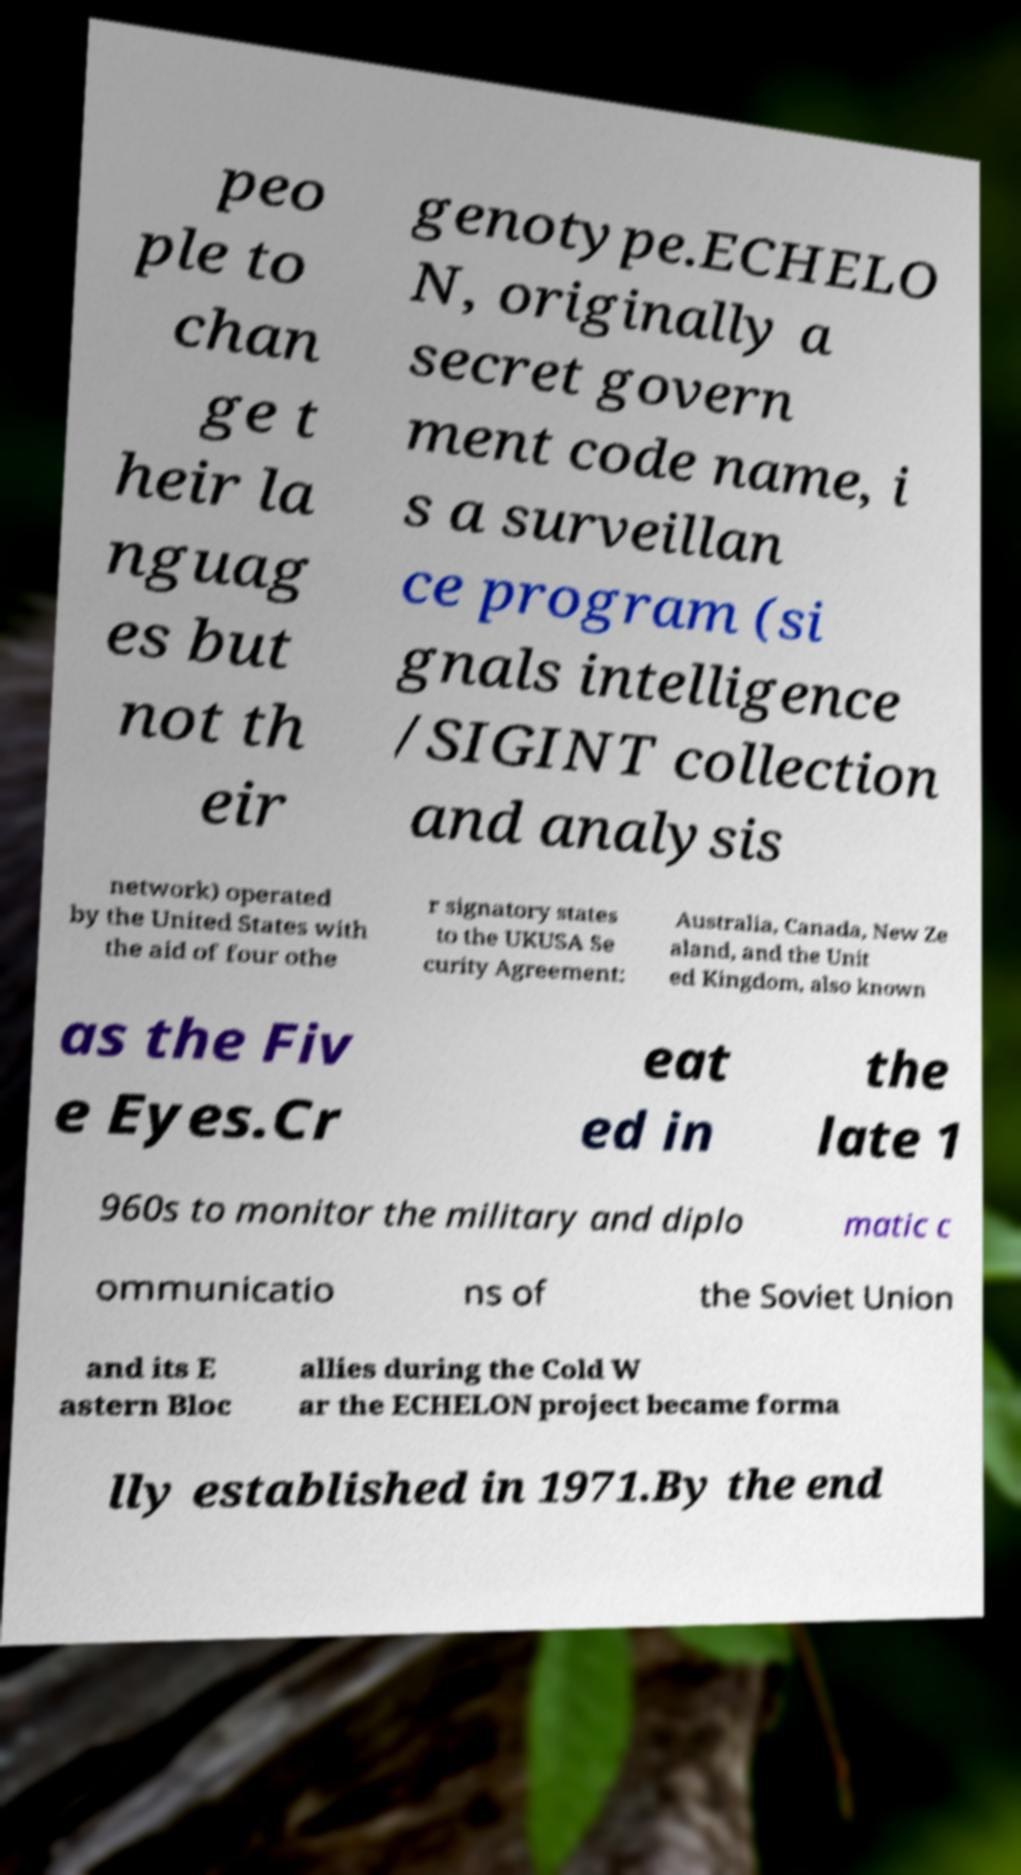Could you extract and type out the text from this image? peo ple to chan ge t heir la nguag es but not th eir genotype.ECHELO N, originally a secret govern ment code name, i s a surveillan ce program (si gnals intelligence /SIGINT collection and analysis network) operated by the United States with the aid of four othe r signatory states to the UKUSA Se curity Agreement: Australia, Canada, New Ze aland, and the Unit ed Kingdom, also known as the Fiv e Eyes.Cr eat ed in the late 1 960s to monitor the military and diplo matic c ommunicatio ns of the Soviet Union and its E astern Bloc allies during the Cold W ar the ECHELON project became forma lly established in 1971.By the end 